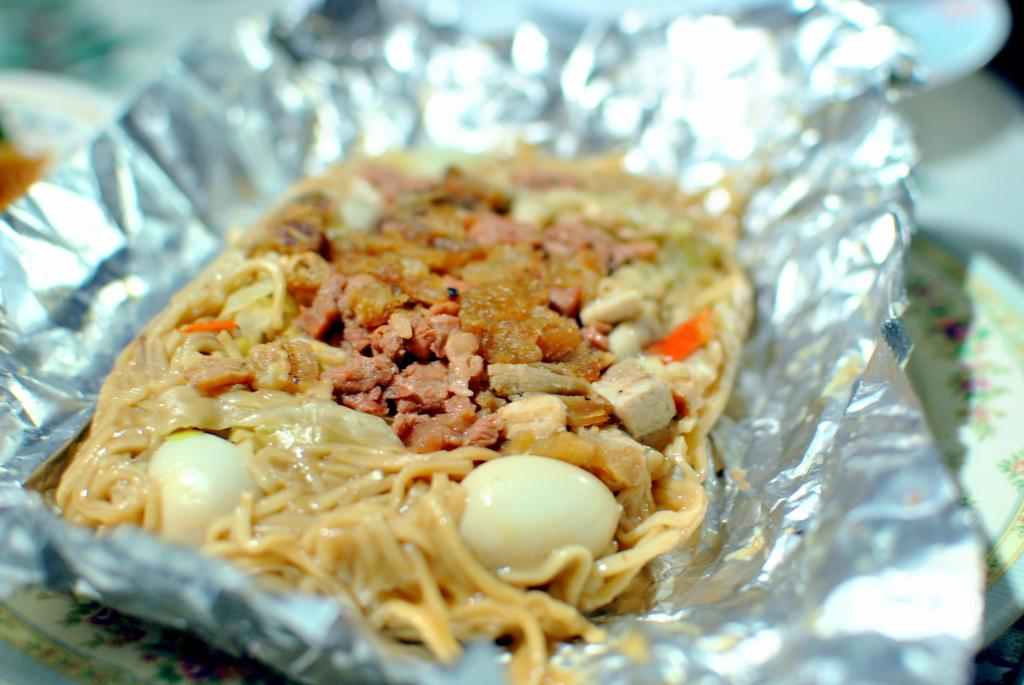What type of material is used to wrap the food in the image? There is aluminium paper in the image. What is inside the aluminium paper? The aluminium paper contains noodles and eggs. On what is the aluminium paper placed? The aluminium paper is placed on a white plate. Can you describe the quality of the image in the background? The image is blurred in the background. What type of poison is hidden in the noodles and eggs in the image? There is no poison present in the image; it contains noodles and eggs wrapped in aluminium paper. 